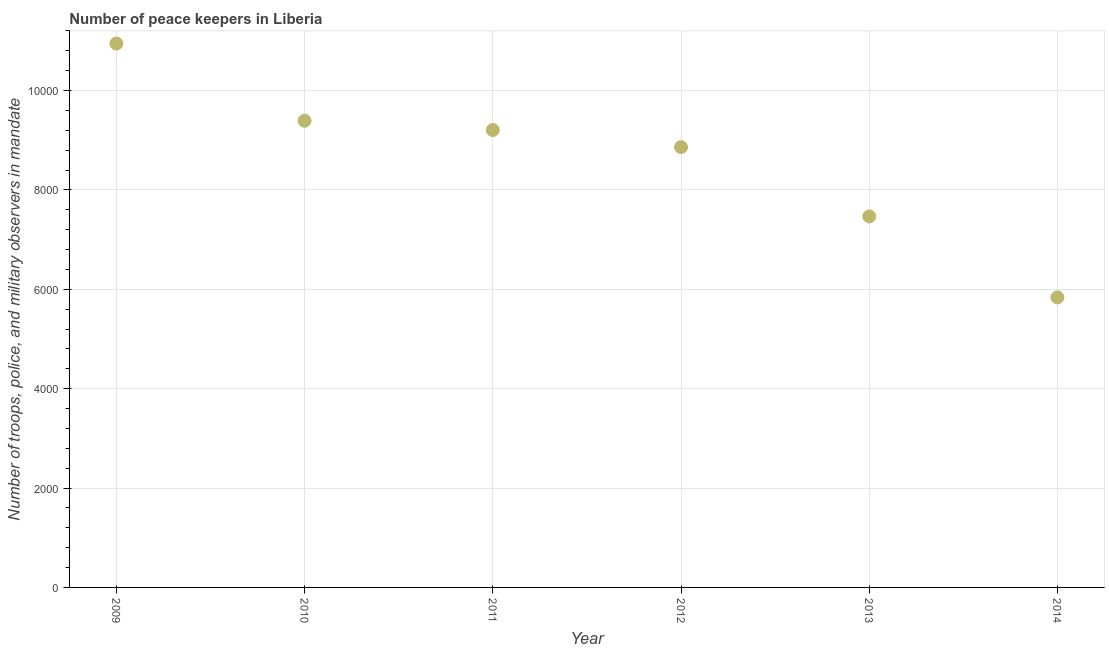What is the number of peace keepers in 2010?
Your response must be concise. 9392. Across all years, what is the maximum number of peace keepers?
Provide a succinct answer. 1.09e+04. Across all years, what is the minimum number of peace keepers?
Offer a terse response. 5838. In which year was the number of peace keepers maximum?
Your answer should be very brief. 2009. In which year was the number of peace keepers minimum?
Your answer should be very brief. 2014. What is the sum of the number of peace keepers?
Your response must be concise. 5.17e+04. What is the difference between the number of peace keepers in 2011 and 2013?
Ensure brevity in your answer.  1739. What is the average number of peace keepers per year?
Your response must be concise. 8618.67. What is the median number of peace keepers?
Offer a terse response. 9034. In how many years, is the number of peace keepers greater than 6000 ?
Offer a terse response. 5. Do a majority of the years between 2012 and 2011 (inclusive) have number of peace keepers greater than 8000 ?
Provide a succinct answer. No. What is the ratio of the number of peace keepers in 2009 to that in 2010?
Offer a terse response. 1.17. Is the difference between the number of peace keepers in 2010 and 2012 greater than the difference between any two years?
Provide a short and direct response. No. What is the difference between the highest and the second highest number of peace keepers?
Your response must be concise. 1555. Is the sum of the number of peace keepers in 2012 and 2013 greater than the maximum number of peace keepers across all years?
Keep it short and to the point. Yes. What is the difference between the highest and the lowest number of peace keepers?
Ensure brevity in your answer.  5109. How many dotlines are there?
Your answer should be very brief. 1. What is the difference between two consecutive major ticks on the Y-axis?
Give a very brief answer. 2000. Does the graph contain grids?
Provide a short and direct response. Yes. What is the title of the graph?
Keep it short and to the point. Number of peace keepers in Liberia. What is the label or title of the X-axis?
Provide a short and direct response. Year. What is the label or title of the Y-axis?
Ensure brevity in your answer.  Number of troops, police, and military observers in mandate. What is the Number of troops, police, and military observers in mandate in 2009?
Your answer should be compact. 1.09e+04. What is the Number of troops, police, and military observers in mandate in 2010?
Provide a succinct answer. 9392. What is the Number of troops, police, and military observers in mandate in 2011?
Keep it short and to the point. 9206. What is the Number of troops, police, and military observers in mandate in 2012?
Keep it short and to the point. 8862. What is the Number of troops, police, and military observers in mandate in 2013?
Offer a terse response. 7467. What is the Number of troops, police, and military observers in mandate in 2014?
Make the answer very short. 5838. What is the difference between the Number of troops, police, and military observers in mandate in 2009 and 2010?
Ensure brevity in your answer.  1555. What is the difference between the Number of troops, police, and military observers in mandate in 2009 and 2011?
Your answer should be very brief. 1741. What is the difference between the Number of troops, police, and military observers in mandate in 2009 and 2012?
Offer a very short reply. 2085. What is the difference between the Number of troops, police, and military observers in mandate in 2009 and 2013?
Make the answer very short. 3480. What is the difference between the Number of troops, police, and military observers in mandate in 2009 and 2014?
Your answer should be compact. 5109. What is the difference between the Number of troops, police, and military observers in mandate in 2010 and 2011?
Provide a short and direct response. 186. What is the difference between the Number of troops, police, and military observers in mandate in 2010 and 2012?
Your response must be concise. 530. What is the difference between the Number of troops, police, and military observers in mandate in 2010 and 2013?
Your answer should be compact. 1925. What is the difference between the Number of troops, police, and military observers in mandate in 2010 and 2014?
Offer a very short reply. 3554. What is the difference between the Number of troops, police, and military observers in mandate in 2011 and 2012?
Ensure brevity in your answer.  344. What is the difference between the Number of troops, police, and military observers in mandate in 2011 and 2013?
Keep it short and to the point. 1739. What is the difference between the Number of troops, police, and military observers in mandate in 2011 and 2014?
Keep it short and to the point. 3368. What is the difference between the Number of troops, police, and military observers in mandate in 2012 and 2013?
Keep it short and to the point. 1395. What is the difference between the Number of troops, police, and military observers in mandate in 2012 and 2014?
Offer a very short reply. 3024. What is the difference between the Number of troops, police, and military observers in mandate in 2013 and 2014?
Your answer should be very brief. 1629. What is the ratio of the Number of troops, police, and military observers in mandate in 2009 to that in 2010?
Ensure brevity in your answer.  1.17. What is the ratio of the Number of troops, police, and military observers in mandate in 2009 to that in 2011?
Give a very brief answer. 1.19. What is the ratio of the Number of troops, police, and military observers in mandate in 2009 to that in 2012?
Give a very brief answer. 1.24. What is the ratio of the Number of troops, police, and military observers in mandate in 2009 to that in 2013?
Ensure brevity in your answer.  1.47. What is the ratio of the Number of troops, police, and military observers in mandate in 2009 to that in 2014?
Make the answer very short. 1.88. What is the ratio of the Number of troops, police, and military observers in mandate in 2010 to that in 2012?
Offer a very short reply. 1.06. What is the ratio of the Number of troops, police, and military observers in mandate in 2010 to that in 2013?
Your answer should be very brief. 1.26. What is the ratio of the Number of troops, police, and military observers in mandate in 2010 to that in 2014?
Your response must be concise. 1.61. What is the ratio of the Number of troops, police, and military observers in mandate in 2011 to that in 2012?
Offer a terse response. 1.04. What is the ratio of the Number of troops, police, and military observers in mandate in 2011 to that in 2013?
Your answer should be compact. 1.23. What is the ratio of the Number of troops, police, and military observers in mandate in 2011 to that in 2014?
Your answer should be very brief. 1.58. What is the ratio of the Number of troops, police, and military observers in mandate in 2012 to that in 2013?
Give a very brief answer. 1.19. What is the ratio of the Number of troops, police, and military observers in mandate in 2012 to that in 2014?
Your answer should be very brief. 1.52. What is the ratio of the Number of troops, police, and military observers in mandate in 2013 to that in 2014?
Keep it short and to the point. 1.28. 